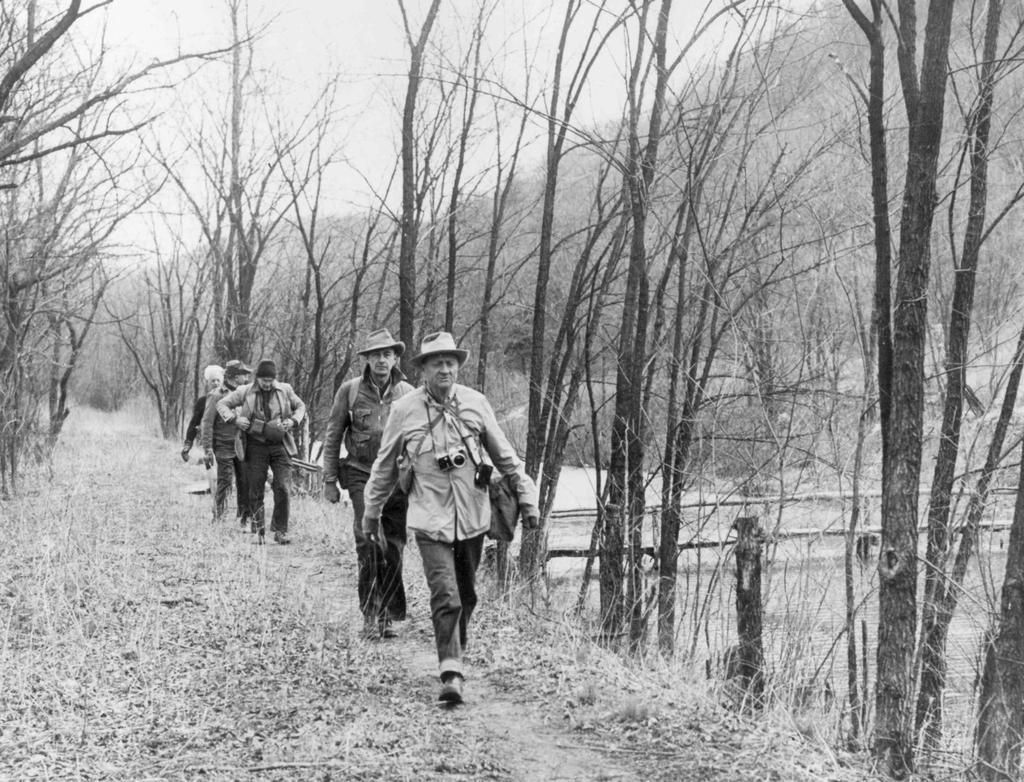How would you summarize this image in a sentence or two? This is a black and white image and there are men walking on the ground. In the background, we can see trees and the sky. 